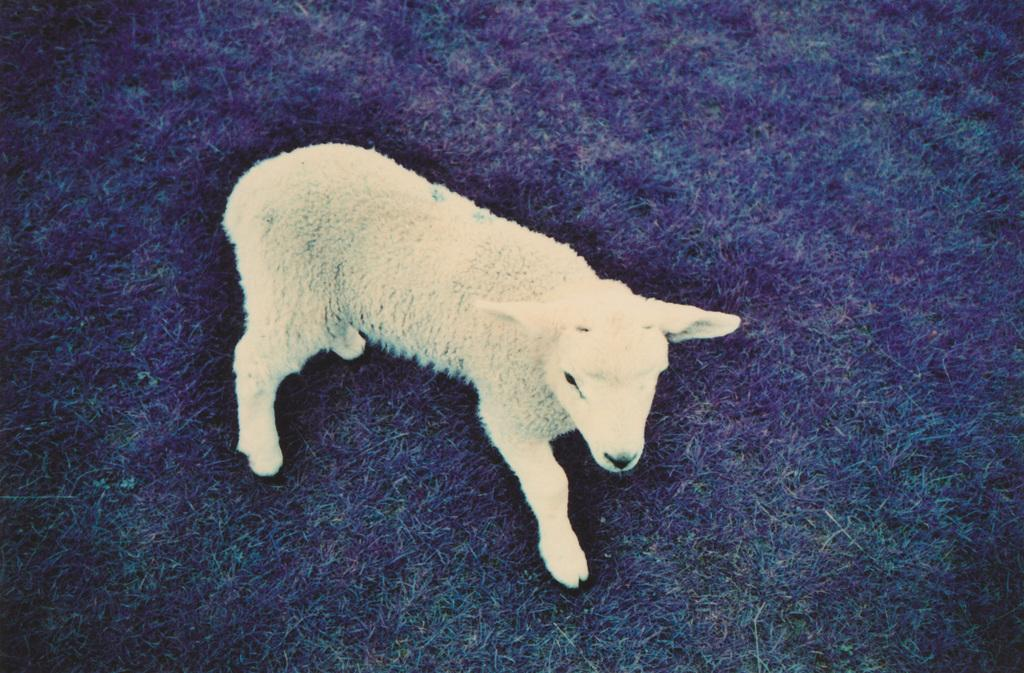What type of animal is in the image? There is a sheep in the image. What color is the sheep? The sheep is white in color. What is the ground covered with in the image? There is green grass on the ground in the image. Where is the scarecrow located in the image? There is no scarecrow present in the image. What type of island can be seen in the background of the image? There is no island visible in the image; it features a sheep on green grass. 